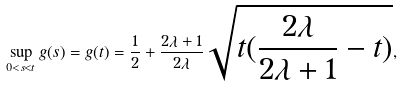<formula> <loc_0><loc_0><loc_500><loc_500>\sup _ { 0 < s < t } g ( s ) = g ( t ) = \frac { 1 } { 2 } + \frac { 2 \lambda + 1 } { 2 \lambda } \sqrt { t ( \frac { 2 \lambda } { 2 \lambda + 1 } - t ) } ,</formula> 